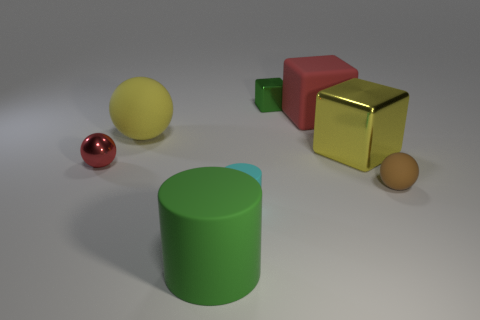Are there the same number of small matte cylinders behind the tiny green thing and blocks?
Provide a short and direct response. No. What number of things are on the right side of the metallic sphere and behind the small cylinder?
Your response must be concise. 5. What size is the yellow object that is the same shape as the brown object?
Keep it short and to the point. Large. How many other large spheres have the same material as the red ball?
Provide a short and direct response. 0. Is the number of big rubber cylinders that are behind the small green cube less than the number of tiny metal cubes?
Keep it short and to the point. Yes. How many yellow objects are there?
Keep it short and to the point. 2. What number of large rubber balls are the same color as the matte cube?
Your answer should be very brief. 0. Do the yellow matte object and the tiny cyan matte thing have the same shape?
Your answer should be very brief. No. What size is the green thing that is on the right side of the tiny matte object that is to the left of the small green shiny block?
Your answer should be very brief. Small. Is there a cyan cylinder that has the same size as the metal ball?
Provide a succinct answer. Yes. 